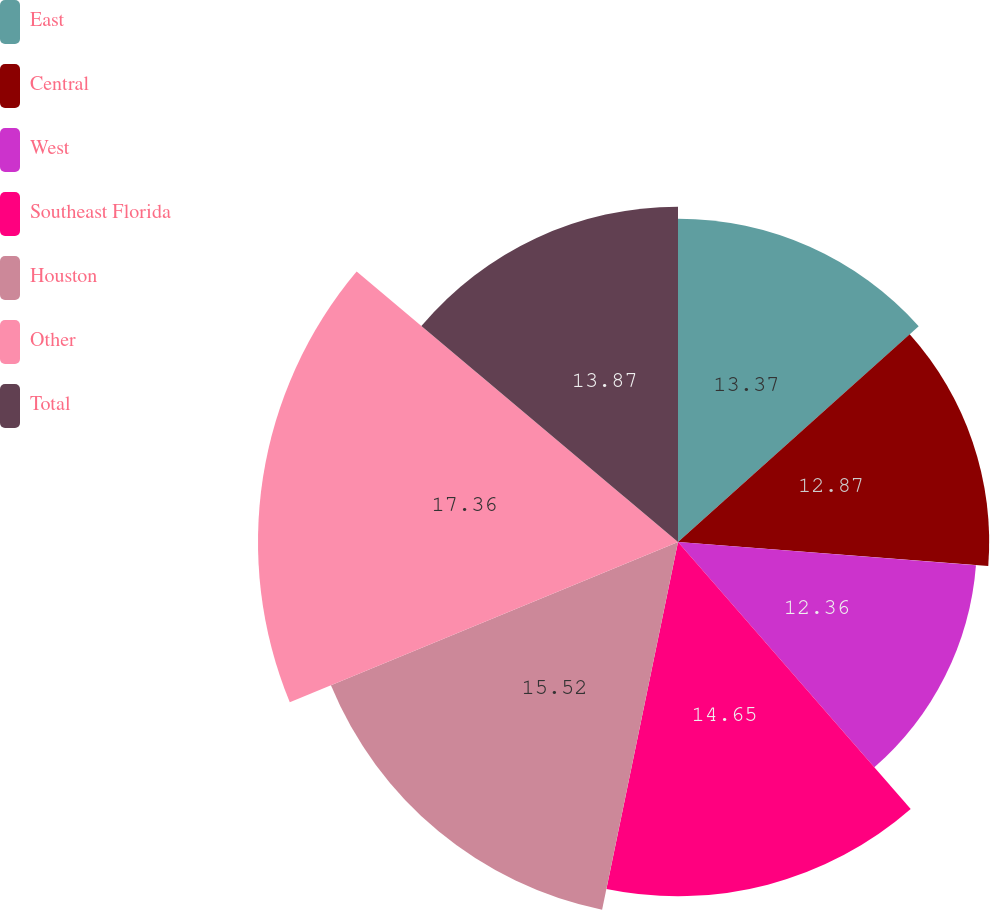<chart> <loc_0><loc_0><loc_500><loc_500><pie_chart><fcel>East<fcel>Central<fcel>West<fcel>Southeast Florida<fcel>Houston<fcel>Other<fcel>Total<nl><fcel>13.37%<fcel>12.87%<fcel>12.36%<fcel>14.65%<fcel>15.53%<fcel>17.37%<fcel>13.87%<nl></chart> 